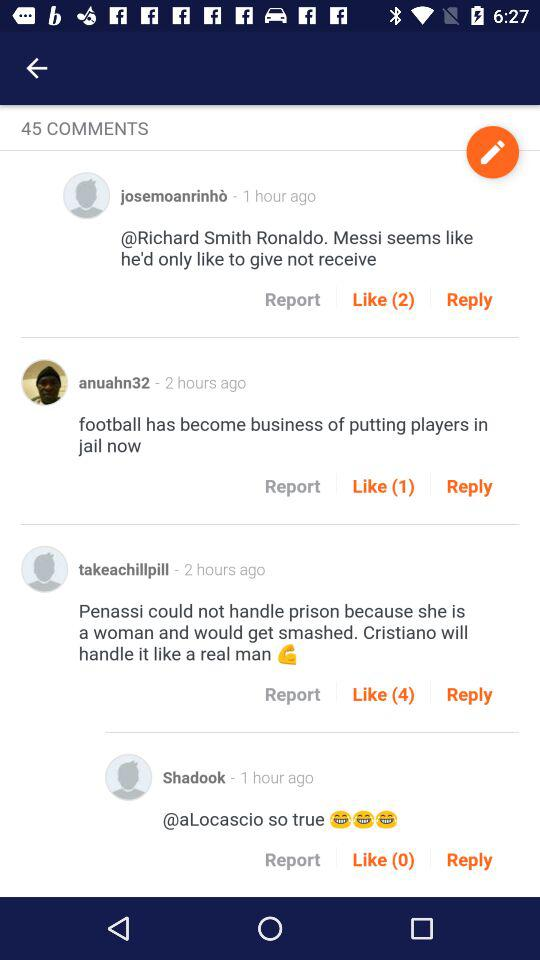How many comments in total are there? There are 45 comments in total. 